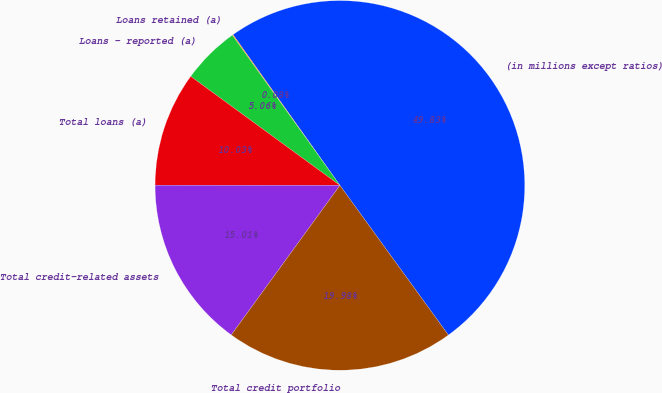Convert chart. <chart><loc_0><loc_0><loc_500><loc_500><pie_chart><fcel>(in millions except ratios)<fcel>Loans retained (a)<fcel>Loans - reported (a)<fcel>Total loans (a)<fcel>Total credit-related assets<fcel>Total credit portfolio<nl><fcel>49.83%<fcel>0.08%<fcel>5.06%<fcel>10.03%<fcel>15.01%<fcel>19.98%<nl></chart> 